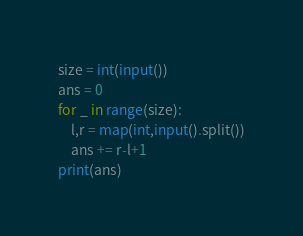<code> <loc_0><loc_0><loc_500><loc_500><_Python_>size = int(input())
ans = 0
for _ in range(size):
    l,r = map(int,input().split())
    ans += r-l+1
print(ans)</code> 